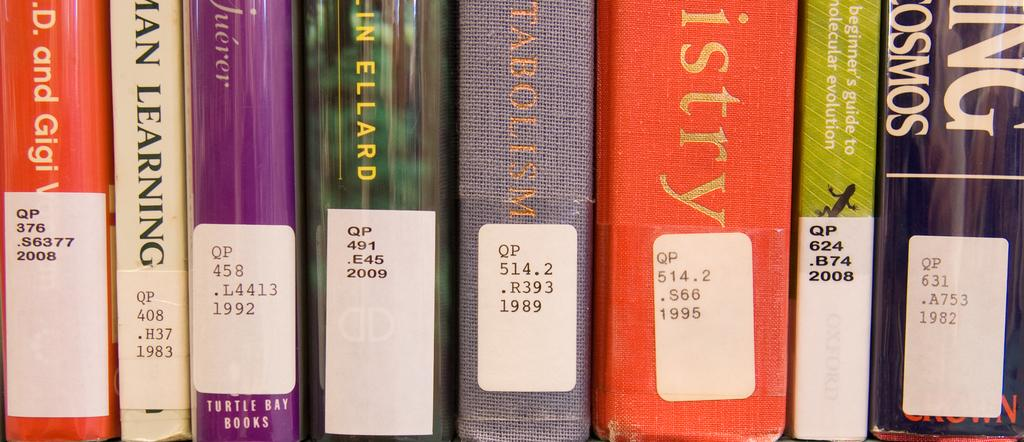<image>
Write a terse but informative summary of the picture. A book about learning is among those labeled and on a shelf. 